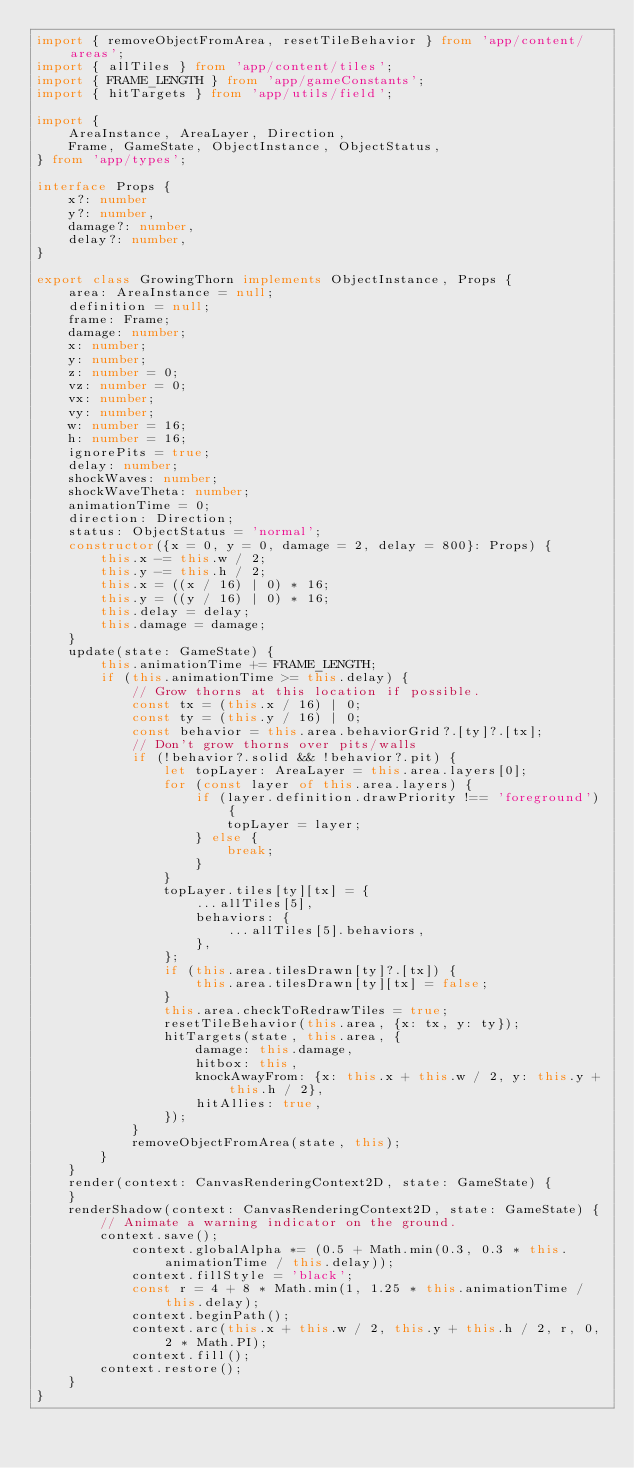Convert code to text. <code><loc_0><loc_0><loc_500><loc_500><_TypeScript_>import { removeObjectFromArea, resetTileBehavior } from 'app/content/areas';
import { allTiles } from 'app/content/tiles';
import { FRAME_LENGTH } from 'app/gameConstants';
import { hitTargets } from 'app/utils/field';

import {
    AreaInstance, AreaLayer, Direction,
    Frame, GameState, ObjectInstance, ObjectStatus,
} from 'app/types';

interface Props {
    x?: number
    y?: number,
    damage?: number,
    delay?: number,
}

export class GrowingThorn implements ObjectInstance, Props {
    area: AreaInstance = null;
    definition = null;
    frame: Frame;
    damage: number;
    x: number;
    y: number;
    z: number = 0;
    vz: number = 0;
    vx: number;
    vy: number;
    w: number = 16;
    h: number = 16;
    ignorePits = true;
    delay: number;
    shockWaves: number;
    shockWaveTheta: number;
    animationTime = 0;
    direction: Direction;
    status: ObjectStatus = 'normal';
    constructor({x = 0, y = 0, damage = 2, delay = 800}: Props) {
        this.x -= this.w / 2;
        this.y -= this.h / 2;
        this.x = ((x / 16) | 0) * 16;
        this.y = ((y / 16) | 0) * 16;
        this.delay = delay;
        this.damage = damage;
    }
    update(state: GameState) {
        this.animationTime += FRAME_LENGTH;
        if (this.animationTime >= this.delay) {
            // Grow thorns at this location if possible.
            const tx = (this.x / 16) | 0;
            const ty = (this.y / 16) | 0;
            const behavior = this.area.behaviorGrid?.[ty]?.[tx];
            // Don't grow thorns over pits/walls
            if (!behavior?.solid && !behavior?.pit) {
                let topLayer: AreaLayer = this.area.layers[0];
                for (const layer of this.area.layers) {
                    if (layer.definition.drawPriority !== 'foreground') {
                        topLayer = layer;
                    } else {
                        break;
                    }
                }
                topLayer.tiles[ty][tx] = {
                    ...allTiles[5],
                    behaviors: {
                        ...allTiles[5].behaviors,
                    },
                };
                if (this.area.tilesDrawn[ty]?.[tx]) {
                    this.area.tilesDrawn[ty][tx] = false;
                }
                this.area.checkToRedrawTiles = true;
                resetTileBehavior(this.area, {x: tx, y: ty});
                hitTargets(state, this.area, {
                    damage: this.damage,
                    hitbox: this,
                    knockAwayFrom: {x: this.x + this.w / 2, y: this.y + this.h / 2},
                    hitAllies: true,
                });
            }
            removeObjectFromArea(state, this);
        }
    }
    render(context: CanvasRenderingContext2D, state: GameState) {
    }
    renderShadow(context: CanvasRenderingContext2D, state: GameState) {
        // Animate a warning indicator on the ground.
        context.save();
            context.globalAlpha *= (0.5 + Math.min(0.3, 0.3 * this.animationTime / this.delay));
            context.fillStyle = 'black';
            const r = 4 + 8 * Math.min(1, 1.25 * this.animationTime / this.delay);
            context.beginPath();
            context.arc(this.x + this.w / 2, this.y + this.h / 2, r, 0, 2 * Math.PI);
            context.fill();
        context.restore();
    }
}
</code> 